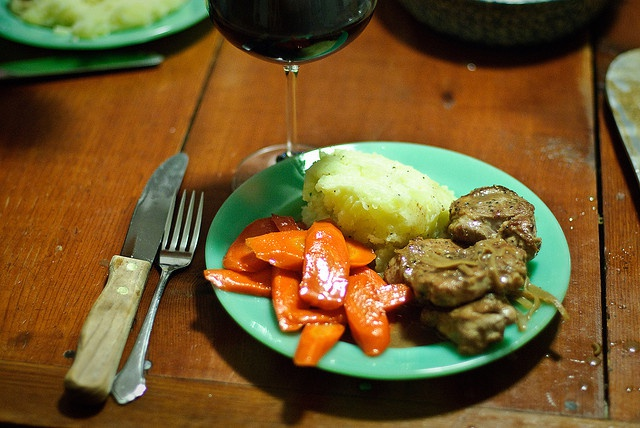Describe the objects in this image and their specific colors. I can see dining table in brown, black, maroon, and olive tones, wine glass in teal, black, brown, olive, and maroon tones, knife in teal, tan, gray, and black tones, carrot in teal, red, orange, and brown tones, and fork in teal, darkgray, gray, and black tones in this image. 